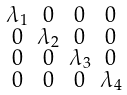<formula> <loc_0><loc_0><loc_500><loc_500>\begin{smallmatrix} \lambda _ { 1 } & 0 & 0 & 0 \\ 0 & \lambda _ { 2 } & 0 & 0 \\ 0 & 0 & \lambda _ { 3 } & 0 \\ 0 & 0 & 0 & \lambda _ { 4 } \end{smallmatrix}</formula> 